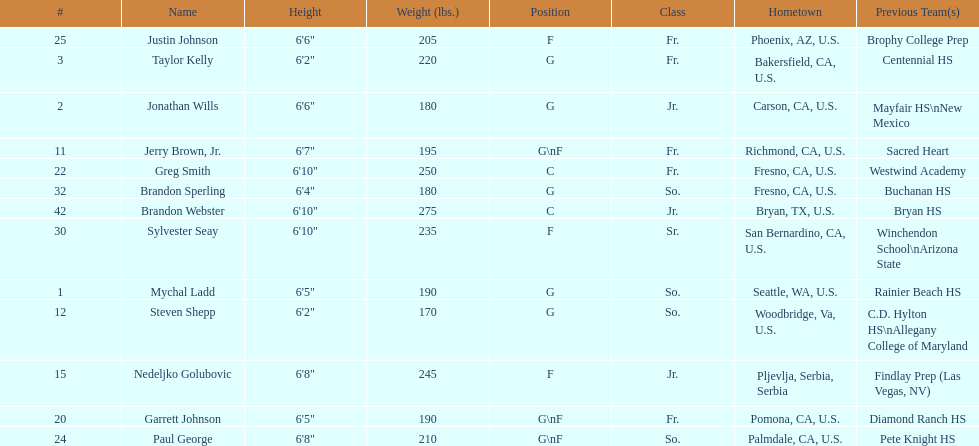What is the number of players who weight over 200 pounds? 7. 